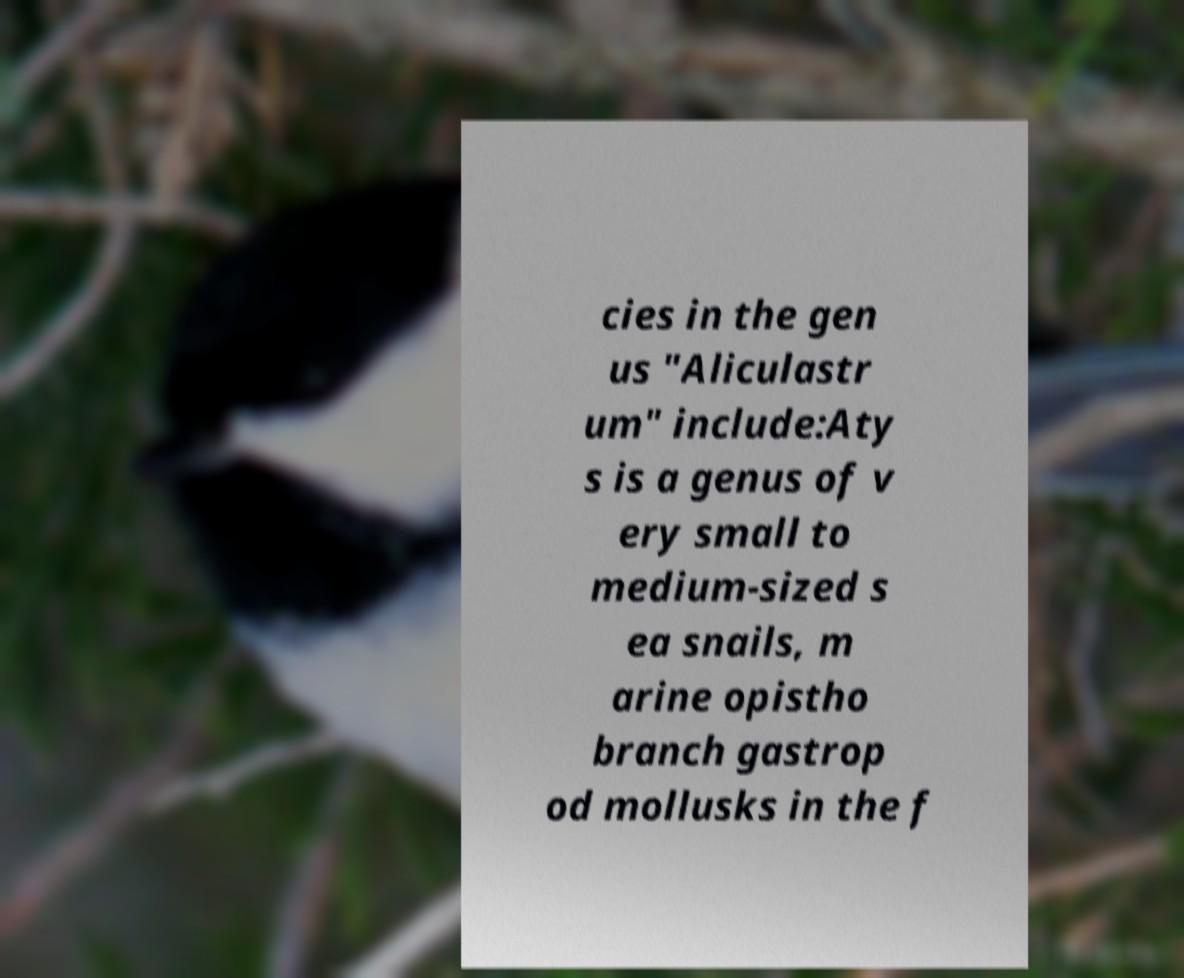There's text embedded in this image that I need extracted. Can you transcribe it verbatim? cies in the gen us "Aliculastr um" include:Aty s is a genus of v ery small to medium-sized s ea snails, m arine opistho branch gastrop od mollusks in the f 